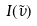Convert formula to latex. <formula><loc_0><loc_0><loc_500><loc_500>I ( \tilde { \nu } )</formula> 